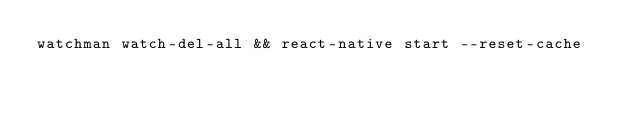<code> <loc_0><loc_0><loc_500><loc_500><_Bash_>watchman watch-del-all && react-native start --reset-cache
</code> 